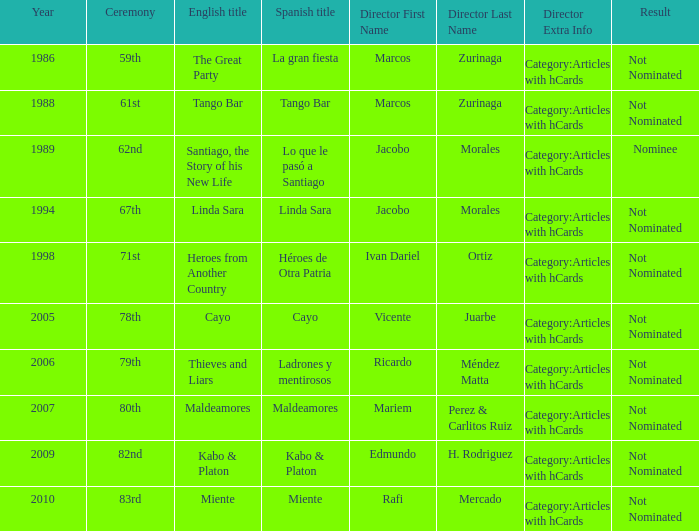I'm looking to parse the entire table for insights. Could you assist me with that? {'header': ['Year', 'Ceremony', 'English title', 'Spanish title', 'Director First Name', 'Director Last Name', 'Director Extra Info', 'Result'], 'rows': [['1986', '59th', 'The Great Party', 'La gran fiesta', 'Marcos', 'Zurinaga', 'Category:Articles with hCards', 'Not Nominated'], ['1988', '61st', 'Tango Bar', 'Tango Bar', 'Marcos', 'Zurinaga', 'Category:Articles with hCards', 'Not Nominated'], ['1989', '62nd', 'Santiago, the Story of his New Life', 'Lo que le pasó a Santiago', 'Jacobo', 'Morales', 'Category:Articles with hCards', 'Nominee'], ['1994', '67th', 'Linda Sara', 'Linda Sara', 'Jacobo', 'Morales', 'Category:Articles with hCards', 'Not Nominated'], ['1998', '71st', 'Heroes from Another Country', 'Héroes de Otra Patria', 'Ivan Dariel', 'Ortiz', 'Category:Articles with hCards', 'Not Nominated'], ['2005', '78th', 'Cayo', 'Cayo', 'Vicente', 'Juarbe', 'Category:Articles with hCards', 'Not Nominated'], ['2006', '79th', 'Thieves and Liars', 'Ladrones y mentirosos', 'Ricardo', 'Méndez Matta', 'Category:Articles with hCards', 'Not Nominated'], ['2007', '80th', 'Maldeamores', 'Maldeamores', 'Mariem', 'Perez & Carlitos Ruiz', 'Category:Articles with hCards', 'Not Nominated'], ['2009', '82nd', 'Kabo & Platon', 'Kabo & Platon', 'Edmundo', 'H. Rodriguez', 'Category:Articles with hCards', 'Not Nominated'], ['2010', '83rd', 'Miente', 'Miente', 'Rafi', 'Mercado', 'Category:Articles with hCards', 'Not Nominated']]} What was the English title fo the film that was a nominee? Santiago, the Story of his New Life. 